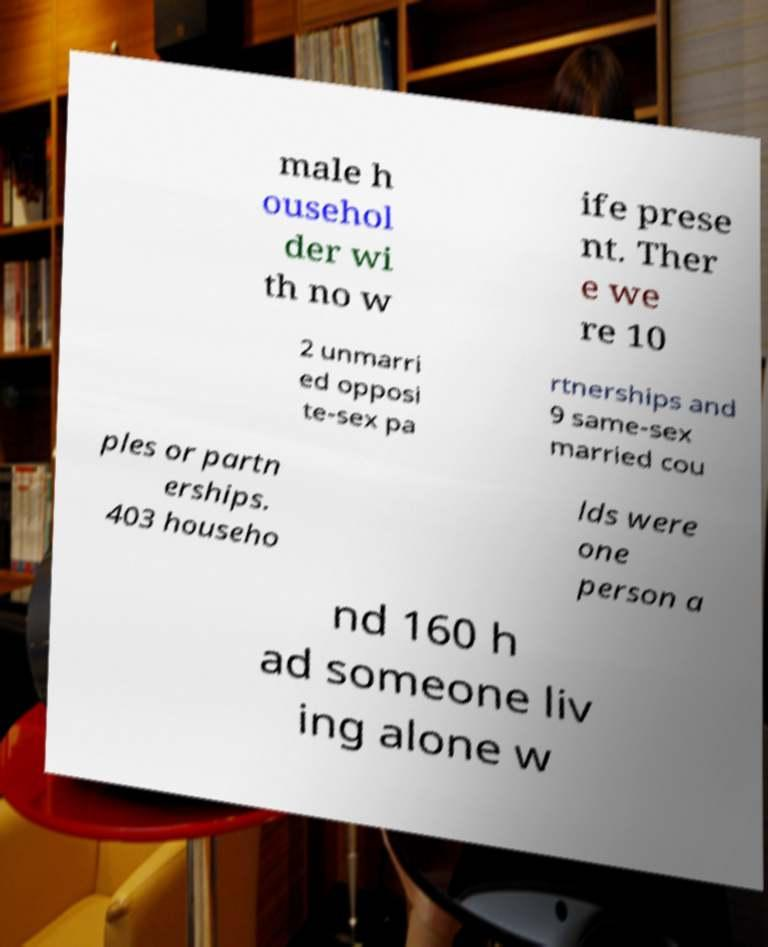Can you read and provide the text displayed in the image?This photo seems to have some interesting text. Can you extract and type it out for me? male h ousehol der wi th no w ife prese nt. Ther e we re 10 2 unmarri ed opposi te-sex pa rtnerships and 9 same-sex married cou ples or partn erships. 403 househo lds were one person a nd 160 h ad someone liv ing alone w 